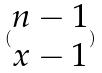<formula> <loc_0><loc_0><loc_500><loc_500>( \begin{matrix} n - 1 \\ x - 1 \end{matrix} )</formula> 